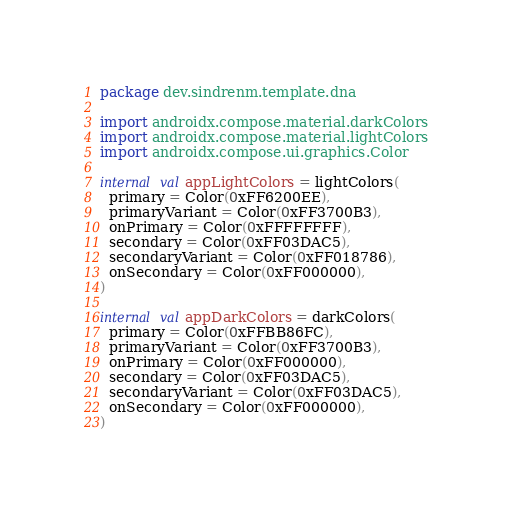Convert code to text. <code><loc_0><loc_0><loc_500><loc_500><_Kotlin_>package dev.sindrenm.template.dna

import androidx.compose.material.darkColors
import androidx.compose.material.lightColors
import androidx.compose.ui.graphics.Color

internal val appLightColors = lightColors(
  primary = Color(0xFF6200EE),
  primaryVariant = Color(0xFF3700B3),
  onPrimary = Color(0xFFFFFFFF),
  secondary = Color(0xFF03DAC5),
  secondaryVariant = Color(0xFF018786),
  onSecondary = Color(0xFF000000),
)

internal val appDarkColors = darkColors(
  primary = Color(0xFFBB86FC),
  primaryVariant = Color(0xFF3700B3),
  onPrimary = Color(0xFF000000),
  secondary = Color(0xFF03DAC5),
  secondaryVariant = Color(0xFF03DAC5),
  onSecondary = Color(0xFF000000),
)
</code> 